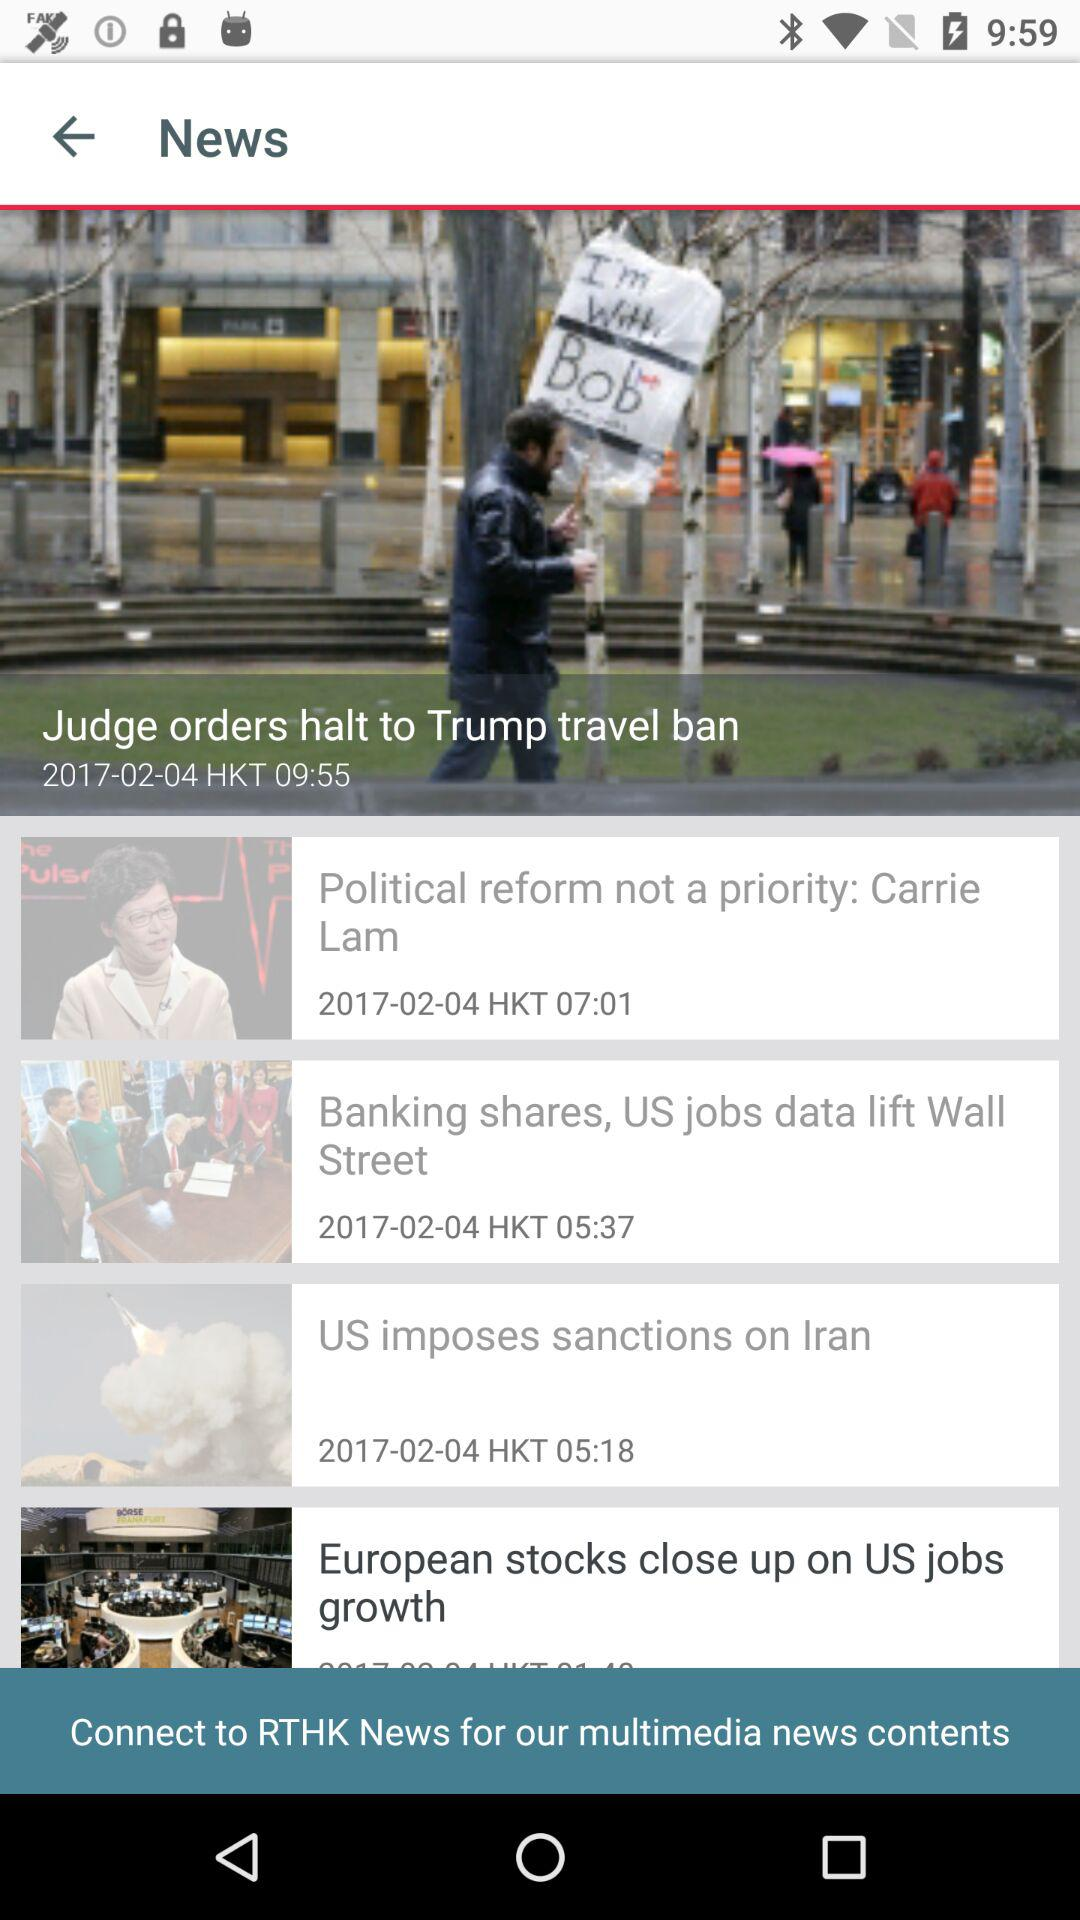On what date was the post "US imposes sanctions on Iran" posted? The post was posted on April 02, 2017. 